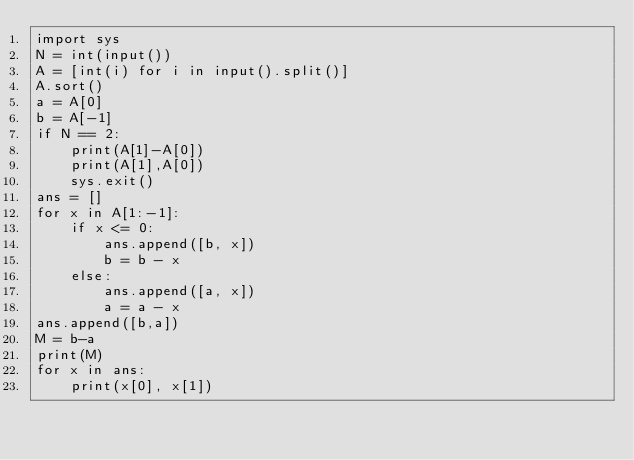<code> <loc_0><loc_0><loc_500><loc_500><_Python_>import sys
N = int(input())
A = [int(i) for i in input().split()]
A.sort()
a = A[0]
b = A[-1]
if N == 2:
    print(A[1]-A[0])
    print(A[1],A[0])
    sys.exit()
ans = []
for x in A[1:-1]:
    if x <= 0:
        ans.append([b, x])
        b = b - x
    else:
        ans.append([a, x])
        a = a - x
ans.append([b,a])
M = b-a
print(M)
for x in ans:
    print(x[0], x[1])
</code> 